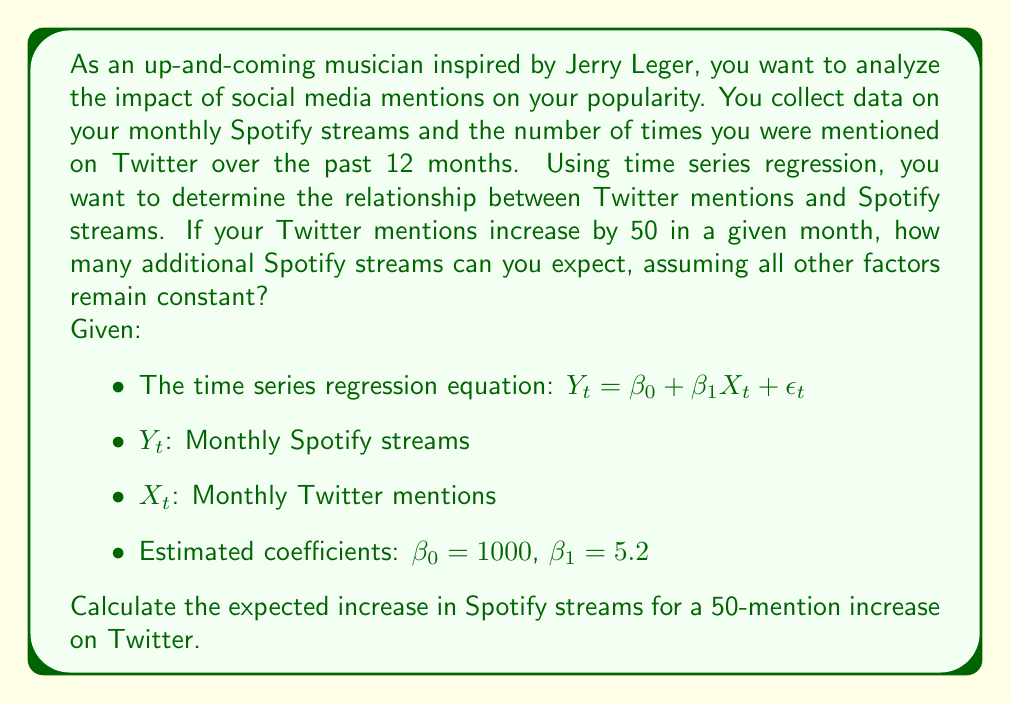Solve this math problem. To solve this problem, we'll use the time series regression equation and the given information. Let's break it down step-by-step:

1. The time series regression equation is given as:
   $$Y_t = \beta_0 + \beta_1X_t + \epsilon_t$$

   Where:
   - $Y_t$ is the dependent variable (Monthly Spotify streams)
   - $X_t$ is the independent variable (Monthly Twitter mentions)
   - $\beta_0$ is the y-intercept (1000)
   - $\beta_1$ is the slope coefficient (5.2)
   - $\epsilon_t$ is the error term

2. We're interested in the change in $Y_t$ when $X_t$ increases by 50. We can ignore the error term $\epsilon_t$ as we're looking at the expected value.

3. The change in $Y_t$ can be calculated by multiplying the change in $X_t$ by $\beta_1$:
   $$\Delta Y_t = \beta_1 \cdot \Delta X_t$$

4. Substituting the values:
   $$\Delta Y_t = 5.2 \cdot 50$$

5. Calculate the result:
   $$\Delta Y_t = 260$$

This means that for a 50-mention increase on Twitter, we can expect an increase of 260 Spotify streams, assuming all other factors remain constant.
Answer: 260 additional Spotify streams 